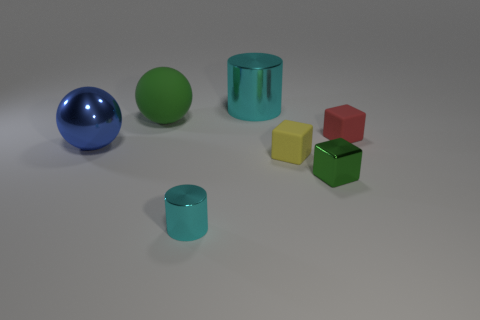There is a small thing that is behind the tiny green shiny object and to the left of the green metal thing; what is its material?
Make the answer very short. Rubber. Are the small yellow cube and the green thing to the right of the big cylinder made of the same material?
Ensure brevity in your answer.  No. What number of objects are both behind the tiny yellow block and to the right of the big green matte sphere?
Offer a very short reply. 2. Do the matte sphere and the small metal cube have the same color?
Offer a very short reply. Yes. What material is the yellow thing that is the same shape as the small red thing?
Keep it short and to the point. Rubber. Are there the same number of tiny cyan metallic cylinders behind the small green metal cube and green shiny objects that are on the left side of the blue shiny sphere?
Keep it short and to the point. Yes. Are the big cyan object and the large green ball made of the same material?
Your answer should be very brief. No. What number of blue objects are either shiny things or big spheres?
Give a very brief answer. 1. What number of other big yellow things have the same shape as the yellow thing?
Provide a short and direct response. 0. What is the material of the small yellow block?
Offer a terse response. Rubber. 